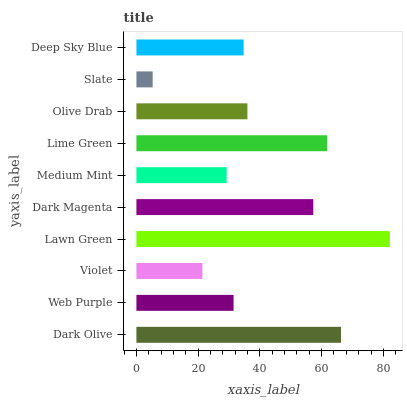Is Slate the minimum?
Answer yes or no. Yes. Is Lawn Green the maximum?
Answer yes or no. Yes. Is Web Purple the minimum?
Answer yes or no. No. Is Web Purple the maximum?
Answer yes or no. No. Is Dark Olive greater than Web Purple?
Answer yes or no. Yes. Is Web Purple less than Dark Olive?
Answer yes or no. Yes. Is Web Purple greater than Dark Olive?
Answer yes or no. No. Is Dark Olive less than Web Purple?
Answer yes or no. No. Is Olive Drab the high median?
Answer yes or no. Yes. Is Deep Sky Blue the low median?
Answer yes or no. Yes. Is Dark Magenta the high median?
Answer yes or no. No. Is Lime Green the low median?
Answer yes or no. No. 